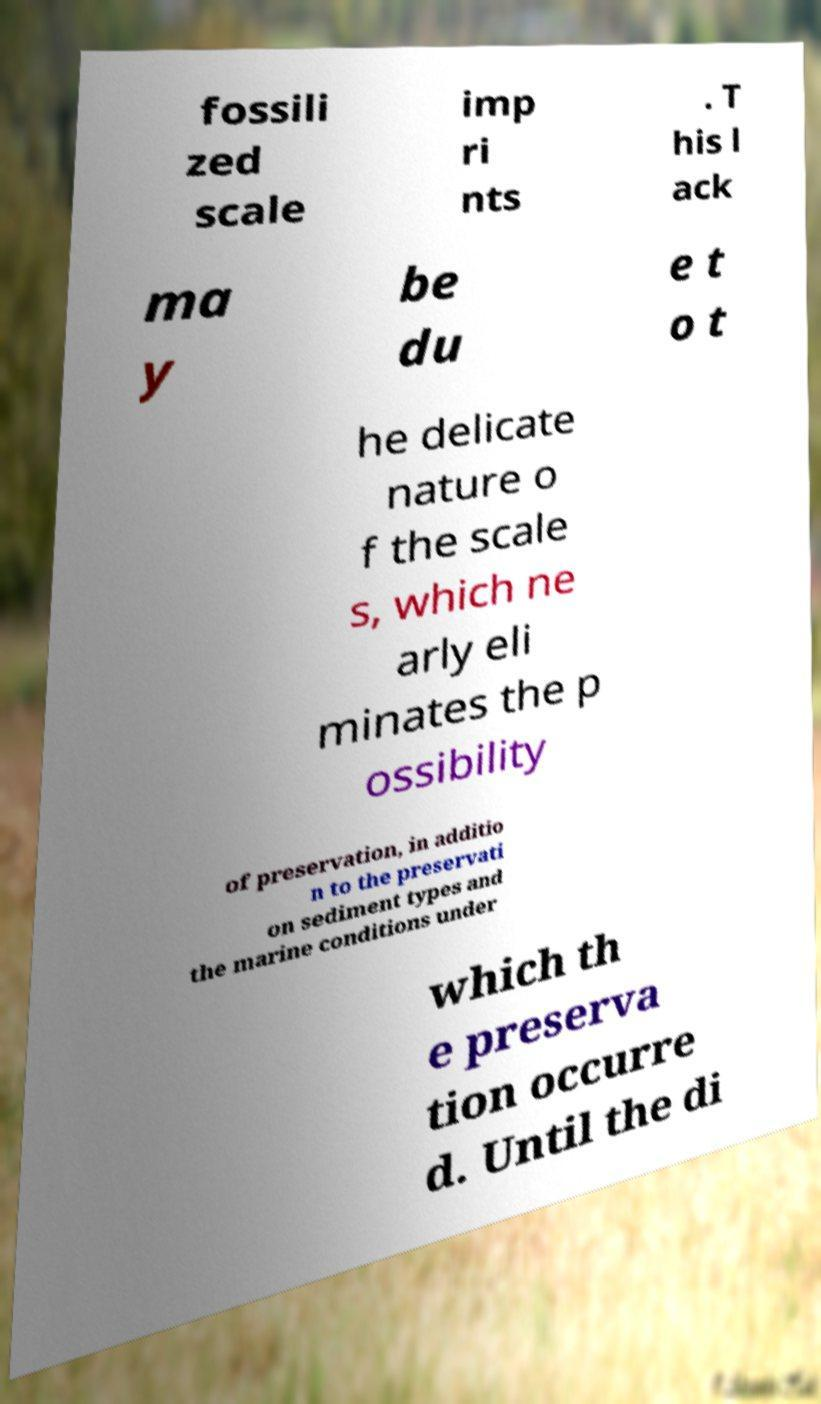Please read and relay the text visible in this image. What does it say? fossili zed scale imp ri nts . T his l ack ma y be du e t o t he delicate nature o f the scale s, which ne arly eli minates the p ossibility of preservation, in additio n to the preservati on sediment types and the marine conditions under which th e preserva tion occurre d. Until the di 